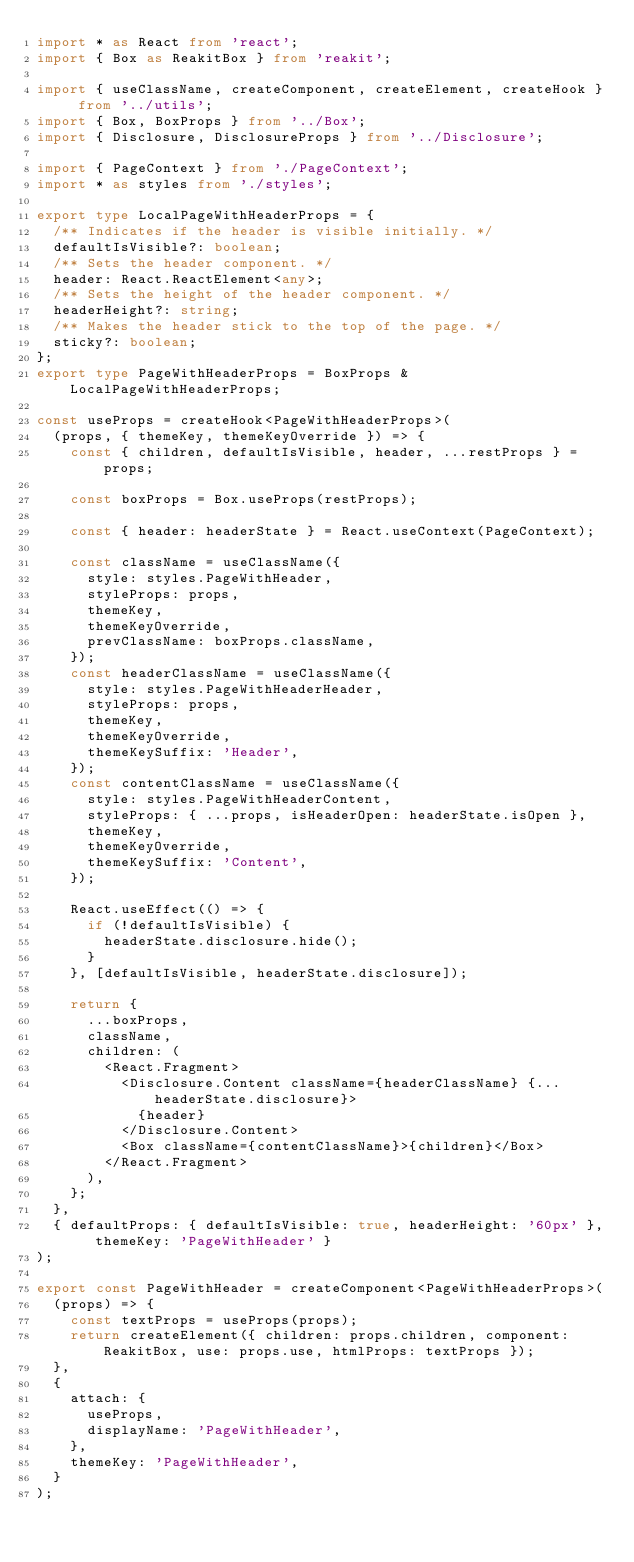Convert code to text. <code><loc_0><loc_0><loc_500><loc_500><_TypeScript_>import * as React from 'react';
import { Box as ReakitBox } from 'reakit';

import { useClassName, createComponent, createElement, createHook } from '../utils';
import { Box, BoxProps } from '../Box';
import { Disclosure, DisclosureProps } from '../Disclosure';

import { PageContext } from './PageContext';
import * as styles from './styles';

export type LocalPageWithHeaderProps = {
  /** Indicates if the header is visible initially. */
  defaultIsVisible?: boolean;
  /** Sets the header component. */
  header: React.ReactElement<any>;
  /** Sets the height of the header component. */
  headerHeight?: string;
  /** Makes the header stick to the top of the page. */
  sticky?: boolean;
};
export type PageWithHeaderProps = BoxProps & LocalPageWithHeaderProps;

const useProps = createHook<PageWithHeaderProps>(
  (props, { themeKey, themeKeyOverride }) => {
    const { children, defaultIsVisible, header, ...restProps } = props;

    const boxProps = Box.useProps(restProps);

    const { header: headerState } = React.useContext(PageContext);

    const className = useClassName({
      style: styles.PageWithHeader,
      styleProps: props,
      themeKey,
      themeKeyOverride,
      prevClassName: boxProps.className,
    });
    const headerClassName = useClassName({
      style: styles.PageWithHeaderHeader,
      styleProps: props,
      themeKey,
      themeKeyOverride,
      themeKeySuffix: 'Header',
    });
    const contentClassName = useClassName({
      style: styles.PageWithHeaderContent,
      styleProps: { ...props, isHeaderOpen: headerState.isOpen },
      themeKey,
      themeKeyOverride,
      themeKeySuffix: 'Content',
    });

    React.useEffect(() => {
      if (!defaultIsVisible) {
        headerState.disclosure.hide();
      }
    }, [defaultIsVisible, headerState.disclosure]);

    return {
      ...boxProps,
      className,
      children: (
        <React.Fragment>
          <Disclosure.Content className={headerClassName} {...headerState.disclosure}>
            {header}
          </Disclosure.Content>
          <Box className={contentClassName}>{children}</Box>
        </React.Fragment>
      ),
    };
  },
  { defaultProps: { defaultIsVisible: true, headerHeight: '60px' }, themeKey: 'PageWithHeader' }
);

export const PageWithHeader = createComponent<PageWithHeaderProps>(
  (props) => {
    const textProps = useProps(props);
    return createElement({ children: props.children, component: ReakitBox, use: props.use, htmlProps: textProps });
  },
  {
    attach: {
      useProps,
      displayName: 'PageWithHeader',
    },
    themeKey: 'PageWithHeader',
  }
);
</code> 